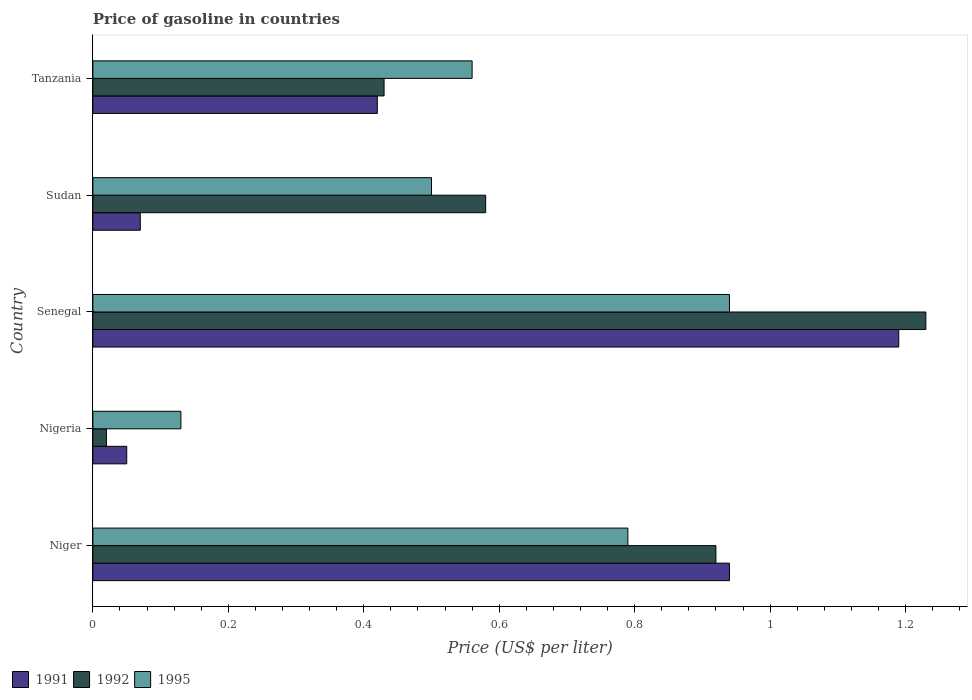How many groups of bars are there?
Provide a succinct answer. 5. Are the number of bars on each tick of the Y-axis equal?
Provide a short and direct response. Yes. How many bars are there on the 5th tick from the bottom?
Your response must be concise. 3. What is the label of the 1st group of bars from the top?
Provide a short and direct response. Tanzania. Across all countries, what is the maximum price of gasoline in 1995?
Your response must be concise. 0.94. In which country was the price of gasoline in 1995 maximum?
Provide a short and direct response. Senegal. In which country was the price of gasoline in 1991 minimum?
Your answer should be very brief. Nigeria. What is the total price of gasoline in 1992 in the graph?
Your response must be concise. 3.18. What is the difference between the price of gasoline in 1992 in Nigeria and that in Sudan?
Provide a succinct answer. -0.56. What is the difference between the price of gasoline in 1991 in Tanzania and the price of gasoline in 1995 in Nigeria?
Provide a short and direct response. 0.29. What is the average price of gasoline in 1992 per country?
Your response must be concise. 0.64. What is the difference between the price of gasoline in 1991 and price of gasoline in 1992 in Tanzania?
Ensure brevity in your answer.  -0.01. What is the ratio of the price of gasoline in 1991 in Niger to that in Senegal?
Your answer should be very brief. 0.79. Is the difference between the price of gasoline in 1991 in Nigeria and Sudan greater than the difference between the price of gasoline in 1992 in Nigeria and Sudan?
Your answer should be very brief. Yes. What is the difference between the highest and the second highest price of gasoline in 1992?
Offer a very short reply. 0.31. What is the difference between the highest and the lowest price of gasoline in 1992?
Offer a very short reply. 1.21. In how many countries, is the price of gasoline in 1992 greater than the average price of gasoline in 1992 taken over all countries?
Provide a succinct answer. 2. What does the 1st bar from the bottom in Tanzania represents?
Give a very brief answer. 1991. Is it the case that in every country, the sum of the price of gasoline in 1992 and price of gasoline in 1991 is greater than the price of gasoline in 1995?
Ensure brevity in your answer.  No. How many countries are there in the graph?
Provide a short and direct response. 5. Are the values on the major ticks of X-axis written in scientific E-notation?
Give a very brief answer. No. Does the graph contain grids?
Offer a terse response. No. Where does the legend appear in the graph?
Keep it short and to the point. Bottom left. What is the title of the graph?
Your answer should be compact. Price of gasoline in countries. What is the label or title of the X-axis?
Offer a terse response. Price (US$ per liter). What is the Price (US$ per liter) of 1992 in Niger?
Provide a short and direct response. 0.92. What is the Price (US$ per liter) in 1995 in Niger?
Provide a short and direct response. 0.79. What is the Price (US$ per liter) of 1991 in Nigeria?
Your answer should be compact. 0.05. What is the Price (US$ per liter) of 1995 in Nigeria?
Ensure brevity in your answer.  0.13. What is the Price (US$ per liter) of 1991 in Senegal?
Make the answer very short. 1.19. What is the Price (US$ per liter) of 1992 in Senegal?
Provide a short and direct response. 1.23. What is the Price (US$ per liter) in 1995 in Senegal?
Make the answer very short. 0.94. What is the Price (US$ per liter) of 1991 in Sudan?
Offer a very short reply. 0.07. What is the Price (US$ per liter) of 1992 in Sudan?
Provide a short and direct response. 0.58. What is the Price (US$ per liter) of 1991 in Tanzania?
Provide a succinct answer. 0.42. What is the Price (US$ per liter) in 1992 in Tanzania?
Provide a short and direct response. 0.43. What is the Price (US$ per liter) in 1995 in Tanzania?
Provide a short and direct response. 0.56. Across all countries, what is the maximum Price (US$ per liter) in 1991?
Keep it short and to the point. 1.19. Across all countries, what is the maximum Price (US$ per liter) in 1992?
Ensure brevity in your answer.  1.23. Across all countries, what is the minimum Price (US$ per liter) in 1991?
Ensure brevity in your answer.  0.05. Across all countries, what is the minimum Price (US$ per liter) in 1992?
Your response must be concise. 0.02. Across all countries, what is the minimum Price (US$ per liter) of 1995?
Offer a very short reply. 0.13. What is the total Price (US$ per liter) in 1991 in the graph?
Your answer should be very brief. 2.67. What is the total Price (US$ per liter) in 1992 in the graph?
Provide a short and direct response. 3.18. What is the total Price (US$ per liter) in 1995 in the graph?
Your answer should be compact. 2.92. What is the difference between the Price (US$ per liter) in 1991 in Niger and that in Nigeria?
Keep it short and to the point. 0.89. What is the difference between the Price (US$ per liter) of 1992 in Niger and that in Nigeria?
Your answer should be very brief. 0.9. What is the difference between the Price (US$ per liter) in 1995 in Niger and that in Nigeria?
Make the answer very short. 0.66. What is the difference between the Price (US$ per liter) of 1992 in Niger and that in Senegal?
Your answer should be very brief. -0.31. What is the difference between the Price (US$ per liter) in 1991 in Niger and that in Sudan?
Give a very brief answer. 0.87. What is the difference between the Price (US$ per liter) of 1992 in Niger and that in Sudan?
Ensure brevity in your answer.  0.34. What is the difference between the Price (US$ per liter) in 1995 in Niger and that in Sudan?
Your answer should be compact. 0.29. What is the difference between the Price (US$ per liter) of 1991 in Niger and that in Tanzania?
Make the answer very short. 0.52. What is the difference between the Price (US$ per liter) of 1992 in Niger and that in Tanzania?
Give a very brief answer. 0.49. What is the difference between the Price (US$ per liter) of 1995 in Niger and that in Tanzania?
Provide a succinct answer. 0.23. What is the difference between the Price (US$ per liter) in 1991 in Nigeria and that in Senegal?
Ensure brevity in your answer.  -1.14. What is the difference between the Price (US$ per liter) in 1992 in Nigeria and that in Senegal?
Offer a terse response. -1.21. What is the difference between the Price (US$ per liter) in 1995 in Nigeria and that in Senegal?
Your answer should be compact. -0.81. What is the difference between the Price (US$ per liter) of 1991 in Nigeria and that in Sudan?
Give a very brief answer. -0.02. What is the difference between the Price (US$ per liter) in 1992 in Nigeria and that in Sudan?
Offer a terse response. -0.56. What is the difference between the Price (US$ per liter) of 1995 in Nigeria and that in Sudan?
Offer a very short reply. -0.37. What is the difference between the Price (US$ per liter) of 1991 in Nigeria and that in Tanzania?
Ensure brevity in your answer.  -0.37. What is the difference between the Price (US$ per liter) in 1992 in Nigeria and that in Tanzania?
Offer a very short reply. -0.41. What is the difference between the Price (US$ per liter) of 1995 in Nigeria and that in Tanzania?
Keep it short and to the point. -0.43. What is the difference between the Price (US$ per liter) of 1991 in Senegal and that in Sudan?
Offer a terse response. 1.12. What is the difference between the Price (US$ per liter) in 1992 in Senegal and that in Sudan?
Your answer should be very brief. 0.65. What is the difference between the Price (US$ per liter) in 1995 in Senegal and that in Sudan?
Provide a short and direct response. 0.44. What is the difference between the Price (US$ per liter) of 1991 in Senegal and that in Tanzania?
Ensure brevity in your answer.  0.77. What is the difference between the Price (US$ per liter) in 1992 in Senegal and that in Tanzania?
Provide a succinct answer. 0.8. What is the difference between the Price (US$ per liter) of 1995 in Senegal and that in Tanzania?
Your answer should be compact. 0.38. What is the difference between the Price (US$ per liter) of 1991 in Sudan and that in Tanzania?
Offer a very short reply. -0.35. What is the difference between the Price (US$ per liter) in 1992 in Sudan and that in Tanzania?
Ensure brevity in your answer.  0.15. What is the difference between the Price (US$ per liter) of 1995 in Sudan and that in Tanzania?
Give a very brief answer. -0.06. What is the difference between the Price (US$ per liter) in 1991 in Niger and the Price (US$ per liter) in 1992 in Nigeria?
Provide a succinct answer. 0.92. What is the difference between the Price (US$ per liter) in 1991 in Niger and the Price (US$ per liter) in 1995 in Nigeria?
Make the answer very short. 0.81. What is the difference between the Price (US$ per liter) of 1992 in Niger and the Price (US$ per liter) of 1995 in Nigeria?
Keep it short and to the point. 0.79. What is the difference between the Price (US$ per liter) of 1991 in Niger and the Price (US$ per liter) of 1992 in Senegal?
Ensure brevity in your answer.  -0.29. What is the difference between the Price (US$ per liter) in 1991 in Niger and the Price (US$ per liter) in 1995 in Senegal?
Provide a succinct answer. 0. What is the difference between the Price (US$ per liter) of 1992 in Niger and the Price (US$ per liter) of 1995 in Senegal?
Offer a very short reply. -0.02. What is the difference between the Price (US$ per liter) in 1991 in Niger and the Price (US$ per liter) in 1992 in Sudan?
Keep it short and to the point. 0.36. What is the difference between the Price (US$ per liter) in 1991 in Niger and the Price (US$ per liter) in 1995 in Sudan?
Keep it short and to the point. 0.44. What is the difference between the Price (US$ per liter) of 1992 in Niger and the Price (US$ per liter) of 1995 in Sudan?
Offer a terse response. 0.42. What is the difference between the Price (US$ per liter) of 1991 in Niger and the Price (US$ per liter) of 1992 in Tanzania?
Offer a very short reply. 0.51. What is the difference between the Price (US$ per liter) of 1991 in Niger and the Price (US$ per liter) of 1995 in Tanzania?
Your answer should be very brief. 0.38. What is the difference between the Price (US$ per liter) in 1992 in Niger and the Price (US$ per liter) in 1995 in Tanzania?
Offer a very short reply. 0.36. What is the difference between the Price (US$ per liter) of 1991 in Nigeria and the Price (US$ per liter) of 1992 in Senegal?
Your answer should be compact. -1.18. What is the difference between the Price (US$ per liter) of 1991 in Nigeria and the Price (US$ per liter) of 1995 in Senegal?
Offer a very short reply. -0.89. What is the difference between the Price (US$ per liter) of 1992 in Nigeria and the Price (US$ per liter) of 1995 in Senegal?
Your response must be concise. -0.92. What is the difference between the Price (US$ per liter) in 1991 in Nigeria and the Price (US$ per liter) in 1992 in Sudan?
Your answer should be compact. -0.53. What is the difference between the Price (US$ per liter) in 1991 in Nigeria and the Price (US$ per liter) in 1995 in Sudan?
Your answer should be very brief. -0.45. What is the difference between the Price (US$ per liter) of 1992 in Nigeria and the Price (US$ per liter) of 1995 in Sudan?
Provide a succinct answer. -0.48. What is the difference between the Price (US$ per liter) in 1991 in Nigeria and the Price (US$ per liter) in 1992 in Tanzania?
Ensure brevity in your answer.  -0.38. What is the difference between the Price (US$ per liter) in 1991 in Nigeria and the Price (US$ per liter) in 1995 in Tanzania?
Your response must be concise. -0.51. What is the difference between the Price (US$ per liter) of 1992 in Nigeria and the Price (US$ per liter) of 1995 in Tanzania?
Give a very brief answer. -0.54. What is the difference between the Price (US$ per liter) in 1991 in Senegal and the Price (US$ per liter) in 1992 in Sudan?
Give a very brief answer. 0.61. What is the difference between the Price (US$ per liter) of 1991 in Senegal and the Price (US$ per liter) of 1995 in Sudan?
Keep it short and to the point. 0.69. What is the difference between the Price (US$ per liter) in 1992 in Senegal and the Price (US$ per liter) in 1995 in Sudan?
Your answer should be compact. 0.73. What is the difference between the Price (US$ per liter) in 1991 in Senegal and the Price (US$ per liter) in 1992 in Tanzania?
Your answer should be very brief. 0.76. What is the difference between the Price (US$ per liter) of 1991 in Senegal and the Price (US$ per liter) of 1995 in Tanzania?
Keep it short and to the point. 0.63. What is the difference between the Price (US$ per liter) of 1992 in Senegal and the Price (US$ per liter) of 1995 in Tanzania?
Provide a succinct answer. 0.67. What is the difference between the Price (US$ per liter) of 1991 in Sudan and the Price (US$ per liter) of 1992 in Tanzania?
Your answer should be very brief. -0.36. What is the difference between the Price (US$ per liter) in 1991 in Sudan and the Price (US$ per liter) in 1995 in Tanzania?
Keep it short and to the point. -0.49. What is the average Price (US$ per liter) of 1991 per country?
Your response must be concise. 0.53. What is the average Price (US$ per liter) in 1992 per country?
Your response must be concise. 0.64. What is the average Price (US$ per liter) of 1995 per country?
Your response must be concise. 0.58. What is the difference between the Price (US$ per liter) in 1991 and Price (US$ per liter) in 1992 in Niger?
Give a very brief answer. 0.02. What is the difference between the Price (US$ per liter) of 1992 and Price (US$ per liter) of 1995 in Niger?
Provide a succinct answer. 0.13. What is the difference between the Price (US$ per liter) of 1991 and Price (US$ per liter) of 1995 in Nigeria?
Provide a succinct answer. -0.08. What is the difference between the Price (US$ per liter) of 1992 and Price (US$ per liter) of 1995 in Nigeria?
Your response must be concise. -0.11. What is the difference between the Price (US$ per liter) of 1991 and Price (US$ per liter) of 1992 in Senegal?
Your answer should be very brief. -0.04. What is the difference between the Price (US$ per liter) of 1991 and Price (US$ per liter) of 1995 in Senegal?
Provide a succinct answer. 0.25. What is the difference between the Price (US$ per liter) in 1992 and Price (US$ per liter) in 1995 in Senegal?
Your answer should be very brief. 0.29. What is the difference between the Price (US$ per liter) of 1991 and Price (US$ per liter) of 1992 in Sudan?
Provide a succinct answer. -0.51. What is the difference between the Price (US$ per liter) in 1991 and Price (US$ per liter) in 1995 in Sudan?
Make the answer very short. -0.43. What is the difference between the Price (US$ per liter) in 1991 and Price (US$ per liter) in 1992 in Tanzania?
Give a very brief answer. -0.01. What is the difference between the Price (US$ per liter) in 1991 and Price (US$ per liter) in 1995 in Tanzania?
Make the answer very short. -0.14. What is the difference between the Price (US$ per liter) in 1992 and Price (US$ per liter) in 1995 in Tanzania?
Give a very brief answer. -0.13. What is the ratio of the Price (US$ per liter) in 1991 in Niger to that in Nigeria?
Your answer should be very brief. 18.8. What is the ratio of the Price (US$ per liter) of 1992 in Niger to that in Nigeria?
Keep it short and to the point. 46. What is the ratio of the Price (US$ per liter) of 1995 in Niger to that in Nigeria?
Give a very brief answer. 6.08. What is the ratio of the Price (US$ per liter) in 1991 in Niger to that in Senegal?
Make the answer very short. 0.79. What is the ratio of the Price (US$ per liter) in 1992 in Niger to that in Senegal?
Keep it short and to the point. 0.75. What is the ratio of the Price (US$ per liter) in 1995 in Niger to that in Senegal?
Give a very brief answer. 0.84. What is the ratio of the Price (US$ per liter) of 1991 in Niger to that in Sudan?
Your answer should be very brief. 13.43. What is the ratio of the Price (US$ per liter) in 1992 in Niger to that in Sudan?
Offer a terse response. 1.59. What is the ratio of the Price (US$ per liter) of 1995 in Niger to that in Sudan?
Your answer should be very brief. 1.58. What is the ratio of the Price (US$ per liter) of 1991 in Niger to that in Tanzania?
Give a very brief answer. 2.24. What is the ratio of the Price (US$ per liter) in 1992 in Niger to that in Tanzania?
Your answer should be compact. 2.14. What is the ratio of the Price (US$ per liter) of 1995 in Niger to that in Tanzania?
Offer a terse response. 1.41. What is the ratio of the Price (US$ per liter) of 1991 in Nigeria to that in Senegal?
Ensure brevity in your answer.  0.04. What is the ratio of the Price (US$ per liter) in 1992 in Nigeria to that in Senegal?
Your answer should be compact. 0.02. What is the ratio of the Price (US$ per liter) of 1995 in Nigeria to that in Senegal?
Provide a short and direct response. 0.14. What is the ratio of the Price (US$ per liter) of 1992 in Nigeria to that in Sudan?
Your answer should be very brief. 0.03. What is the ratio of the Price (US$ per liter) in 1995 in Nigeria to that in Sudan?
Make the answer very short. 0.26. What is the ratio of the Price (US$ per liter) of 1991 in Nigeria to that in Tanzania?
Your response must be concise. 0.12. What is the ratio of the Price (US$ per liter) of 1992 in Nigeria to that in Tanzania?
Provide a succinct answer. 0.05. What is the ratio of the Price (US$ per liter) of 1995 in Nigeria to that in Tanzania?
Provide a short and direct response. 0.23. What is the ratio of the Price (US$ per liter) of 1992 in Senegal to that in Sudan?
Offer a terse response. 2.12. What is the ratio of the Price (US$ per liter) in 1995 in Senegal to that in Sudan?
Keep it short and to the point. 1.88. What is the ratio of the Price (US$ per liter) in 1991 in Senegal to that in Tanzania?
Your response must be concise. 2.83. What is the ratio of the Price (US$ per liter) in 1992 in Senegal to that in Tanzania?
Keep it short and to the point. 2.86. What is the ratio of the Price (US$ per liter) in 1995 in Senegal to that in Tanzania?
Provide a succinct answer. 1.68. What is the ratio of the Price (US$ per liter) in 1992 in Sudan to that in Tanzania?
Offer a terse response. 1.35. What is the ratio of the Price (US$ per liter) of 1995 in Sudan to that in Tanzania?
Your response must be concise. 0.89. What is the difference between the highest and the second highest Price (US$ per liter) of 1992?
Give a very brief answer. 0.31. What is the difference between the highest and the lowest Price (US$ per liter) in 1991?
Your answer should be very brief. 1.14. What is the difference between the highest and the lowest Price (US$ per liter) in 1992?
Offer a very short reply. 1.21. What is the difference between the highest and the lowest Price (US$ per liter) in 1995?
Offer a very short reply. 0.81. 